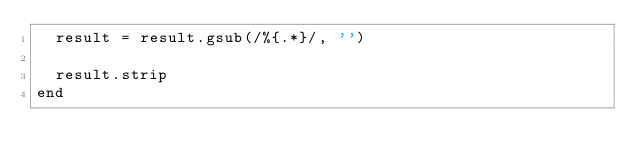Convert code to text. <code><loc_0><loc_0><loc_500><loc_500><_Ruby_>  result = result.gsub(/%{.*}/, '')

  result.strip
end
</code> 